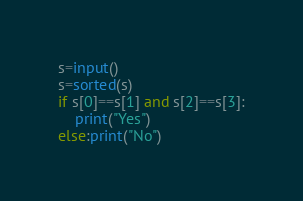Convert code to text. <code><loc_0><loc_0><loc_500><loc_500><_Python_>s=input()
s=sorted(s)
if s[0]==s[1] and s[2]==s[3]:
    print("Yes")
else:print("No")</code> 